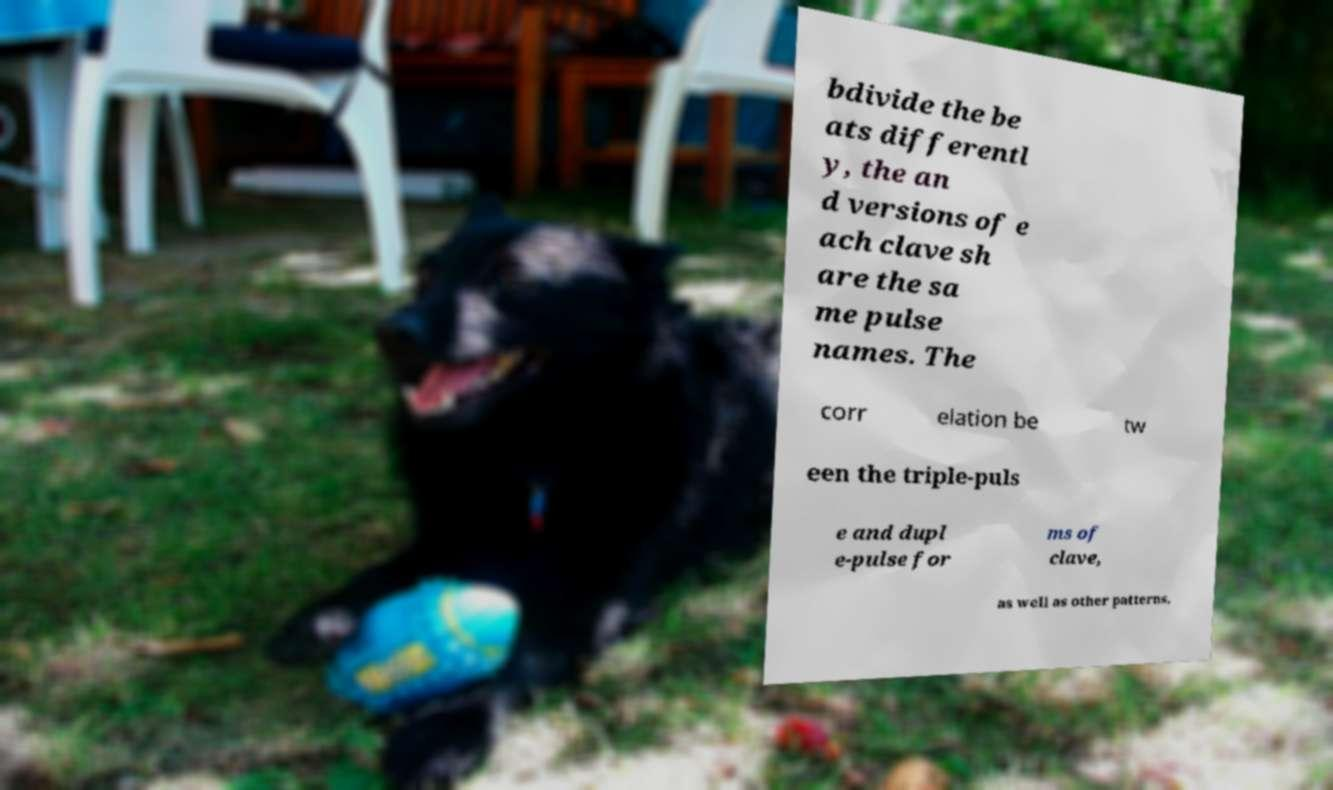Can you read and provide the text displayed in the image?This photo seems to have some interesting text. Can you extract and type it out for me? bdivide the be ats differentl y, the an d versions of e ach clave sh are the sa me pulse names. The corr elation be tw een the triple-puls e and dupl e-pulse for ms of clave, as well as other patterns, 